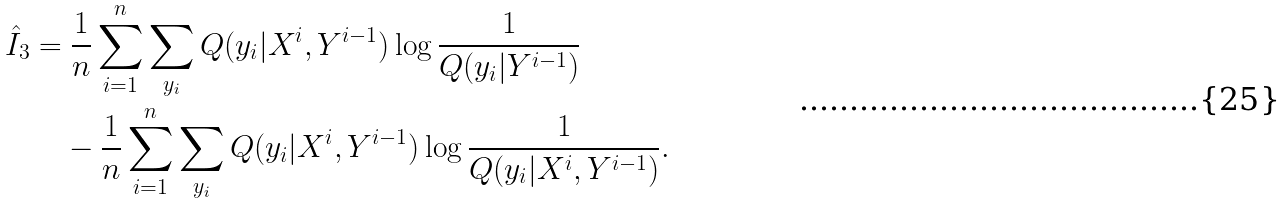<formula> <loc_0><loc_0><loc_500><loc_500>\hat { I } _ { 3 } & = \frac { 1 } { n } \sum _ { i = 1 } ^ { n } \sum _ { y _ { i } } Q ( y _ { i } | X ^ { i } , Y ^ { i - 1 } ) \log \frac { 1 } { Q ( y _ { i } | Y ^ { i - 1 } ) } \\ & \quad - \frac { 1 } { n } \sum _ { i = 1 } ^ { n } \sum _ { y _ { i } } Q ( y _ { i } | X ^ { i } , Y ^ { i - 1 } ) \log \frac { 1 } { Q ( y _ { i } | X ^ { i } , Y ^ { i - 1 } ) } .</formula> 